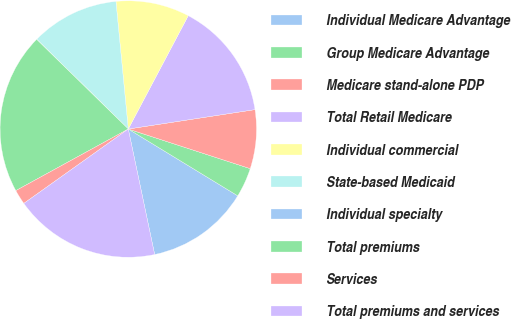Convert chart. <chart><loc_0><loc_0><loc_500><loc_500><pie_chart><fcel>Individual Medicare Advantage<fcel>Group Medicare Advantage<fcel>Medicare stand-alone PDP<fcel>Total Retail Medicare<fcel>Individual commercial<fcel>State-based Medicaid<fcel>Individual specialty<fcel>Total premiums<fcel>Services<fcel>Total premiums and services<nl><fcel>12.98%<fcel>3.72%<fcel>7.42%<fcel>14.83%<fcel>9.28%<fcel>11.13%<fcel>0.01%<fcel>20.3%<fcel>1.87%<fcel>18.45%<nl></chart> 